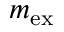<formula> <loc_0><loc_0><loc_500><loc_500>m _ { e x }</formula> 